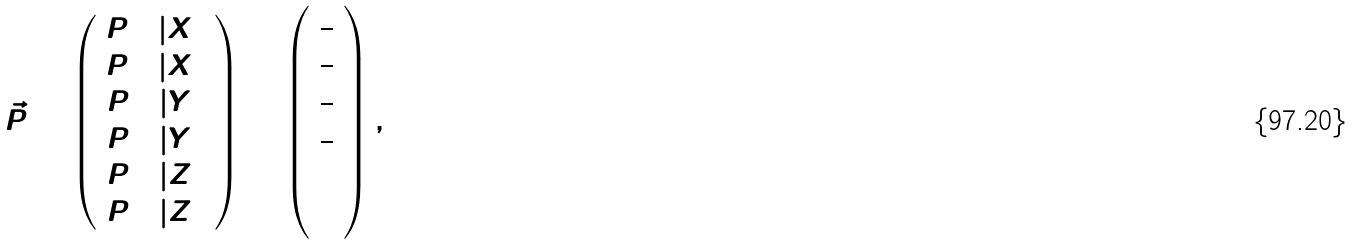<formula> <loc_0><loc_0><loc_500><loc_500>\vec { P } = \left ( \begin{array} { c } P ( 0 | X ) \\ P ( 1 | X ) \\ P ( 0 | Y ) \\ P ( 1 | Y ) \\ P ( 0 | Z ) \\ P ( 1 | Z ) \end{array} \right ) = \left ( \begin{array} { c } \frac { 1 } { 2 } \\ \frac { 1 } { 2 } \\ \frac { 1 } { 2 } \\ \frac { 1 } { 2 } \\ 1 \\ 0 \end{array} \right ) ,</formula> 